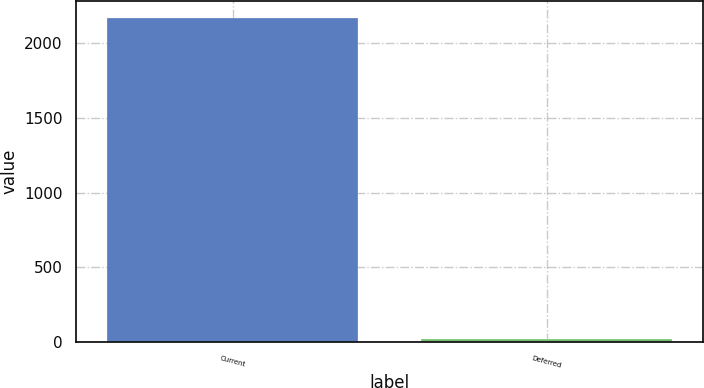<chart> <loc_0><loc_0><loc_500><loc_500><bar_chart><fcel>Current<fcel>Deferred<nl><fcel>2170<fcel>17<nl></chart> 